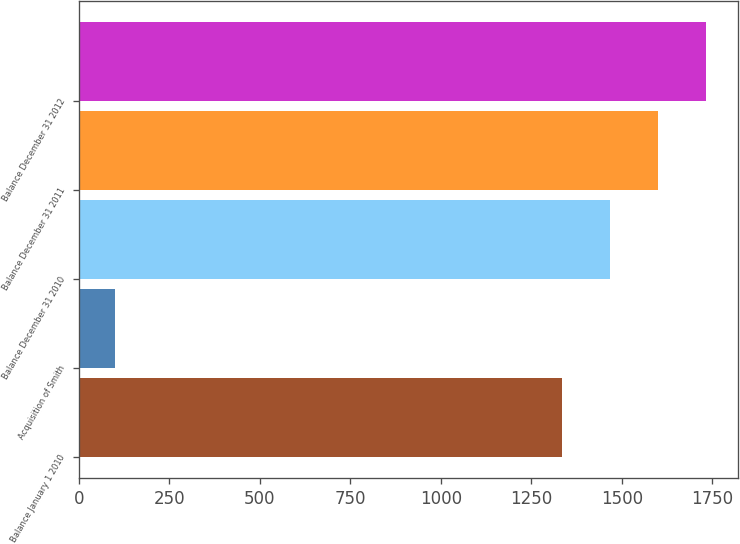<chart> <loc_0><loc_0><loc_500><loc_500><bar_chart><fcel>Balance January 1 2010<fcel>Acquisition of Smith<fcel>Balance December 31 2010<fcel>Balance December 31 2011<fcel>Balance December 31 2012<nl><fcel>1334<fcel>100<fcel>1467.4<fcel>1600.8<fcel>1734.2<nl></chart> 